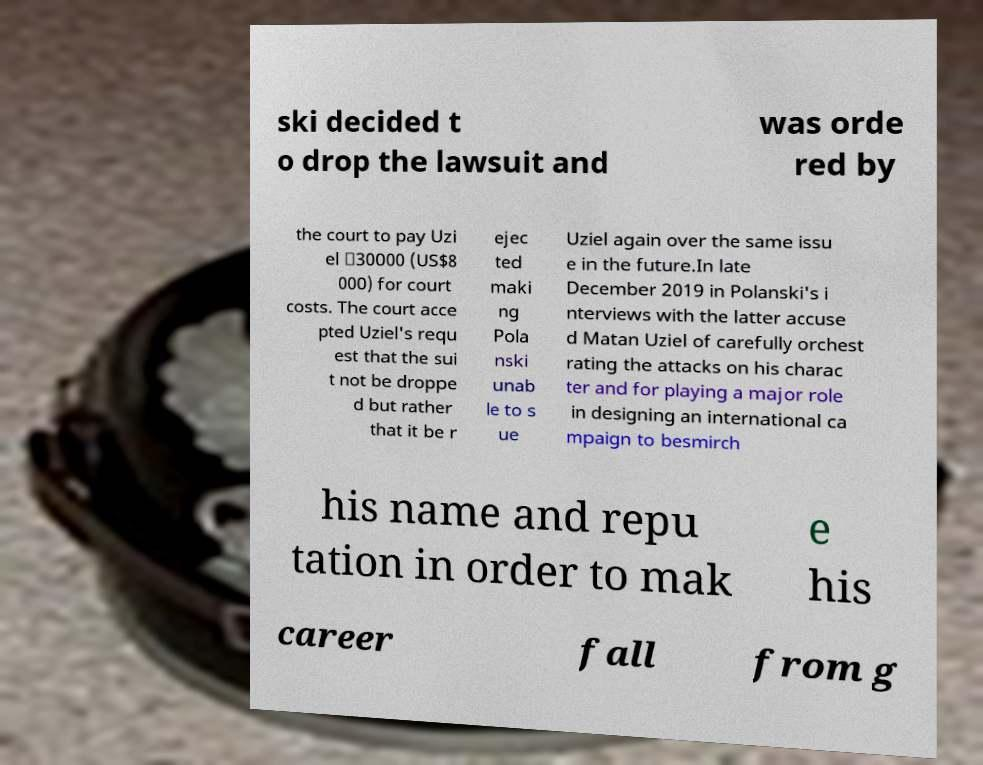For documentation purposes, I need the text within this image transcribed. Could you provide that? ski decided t o drop the lawsuit and was orde red by the court to pay Uzi el ₪30000 (US$8 000) for court costs. The court acce pted Uziel's requ est that the sui t not be droppe d but rather that it be r ejec ted maki ng Pola nski unab le to s ue Uziel again over the same issu e in the future.In late December 2019 in Polanski's i nterviews with the latter accuse d Matan Uziel of carefully orchest rating the attacks on his charac ter and for playing a major role in designing an international ca mpaign to besmirch his name and repu tation in order to mak e his career fall from g 